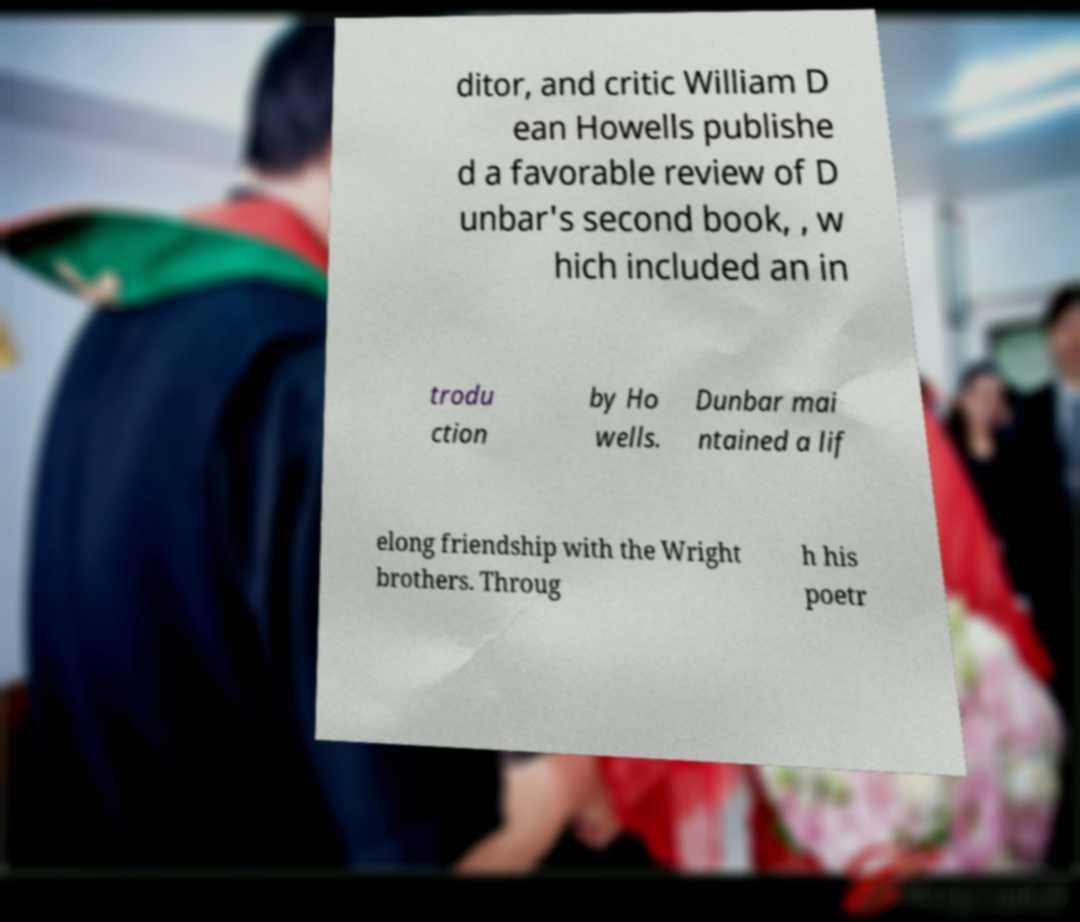Please identify and transcribe the text found in this image. ditor, and critic William D ean Howells publishe d a favorable review of D unbar's second book, , w hich included an in trodu ction by Ho wells. Dunbar mai ntained a lif elong friendship with the Wright brothers. Throug h his poetr 